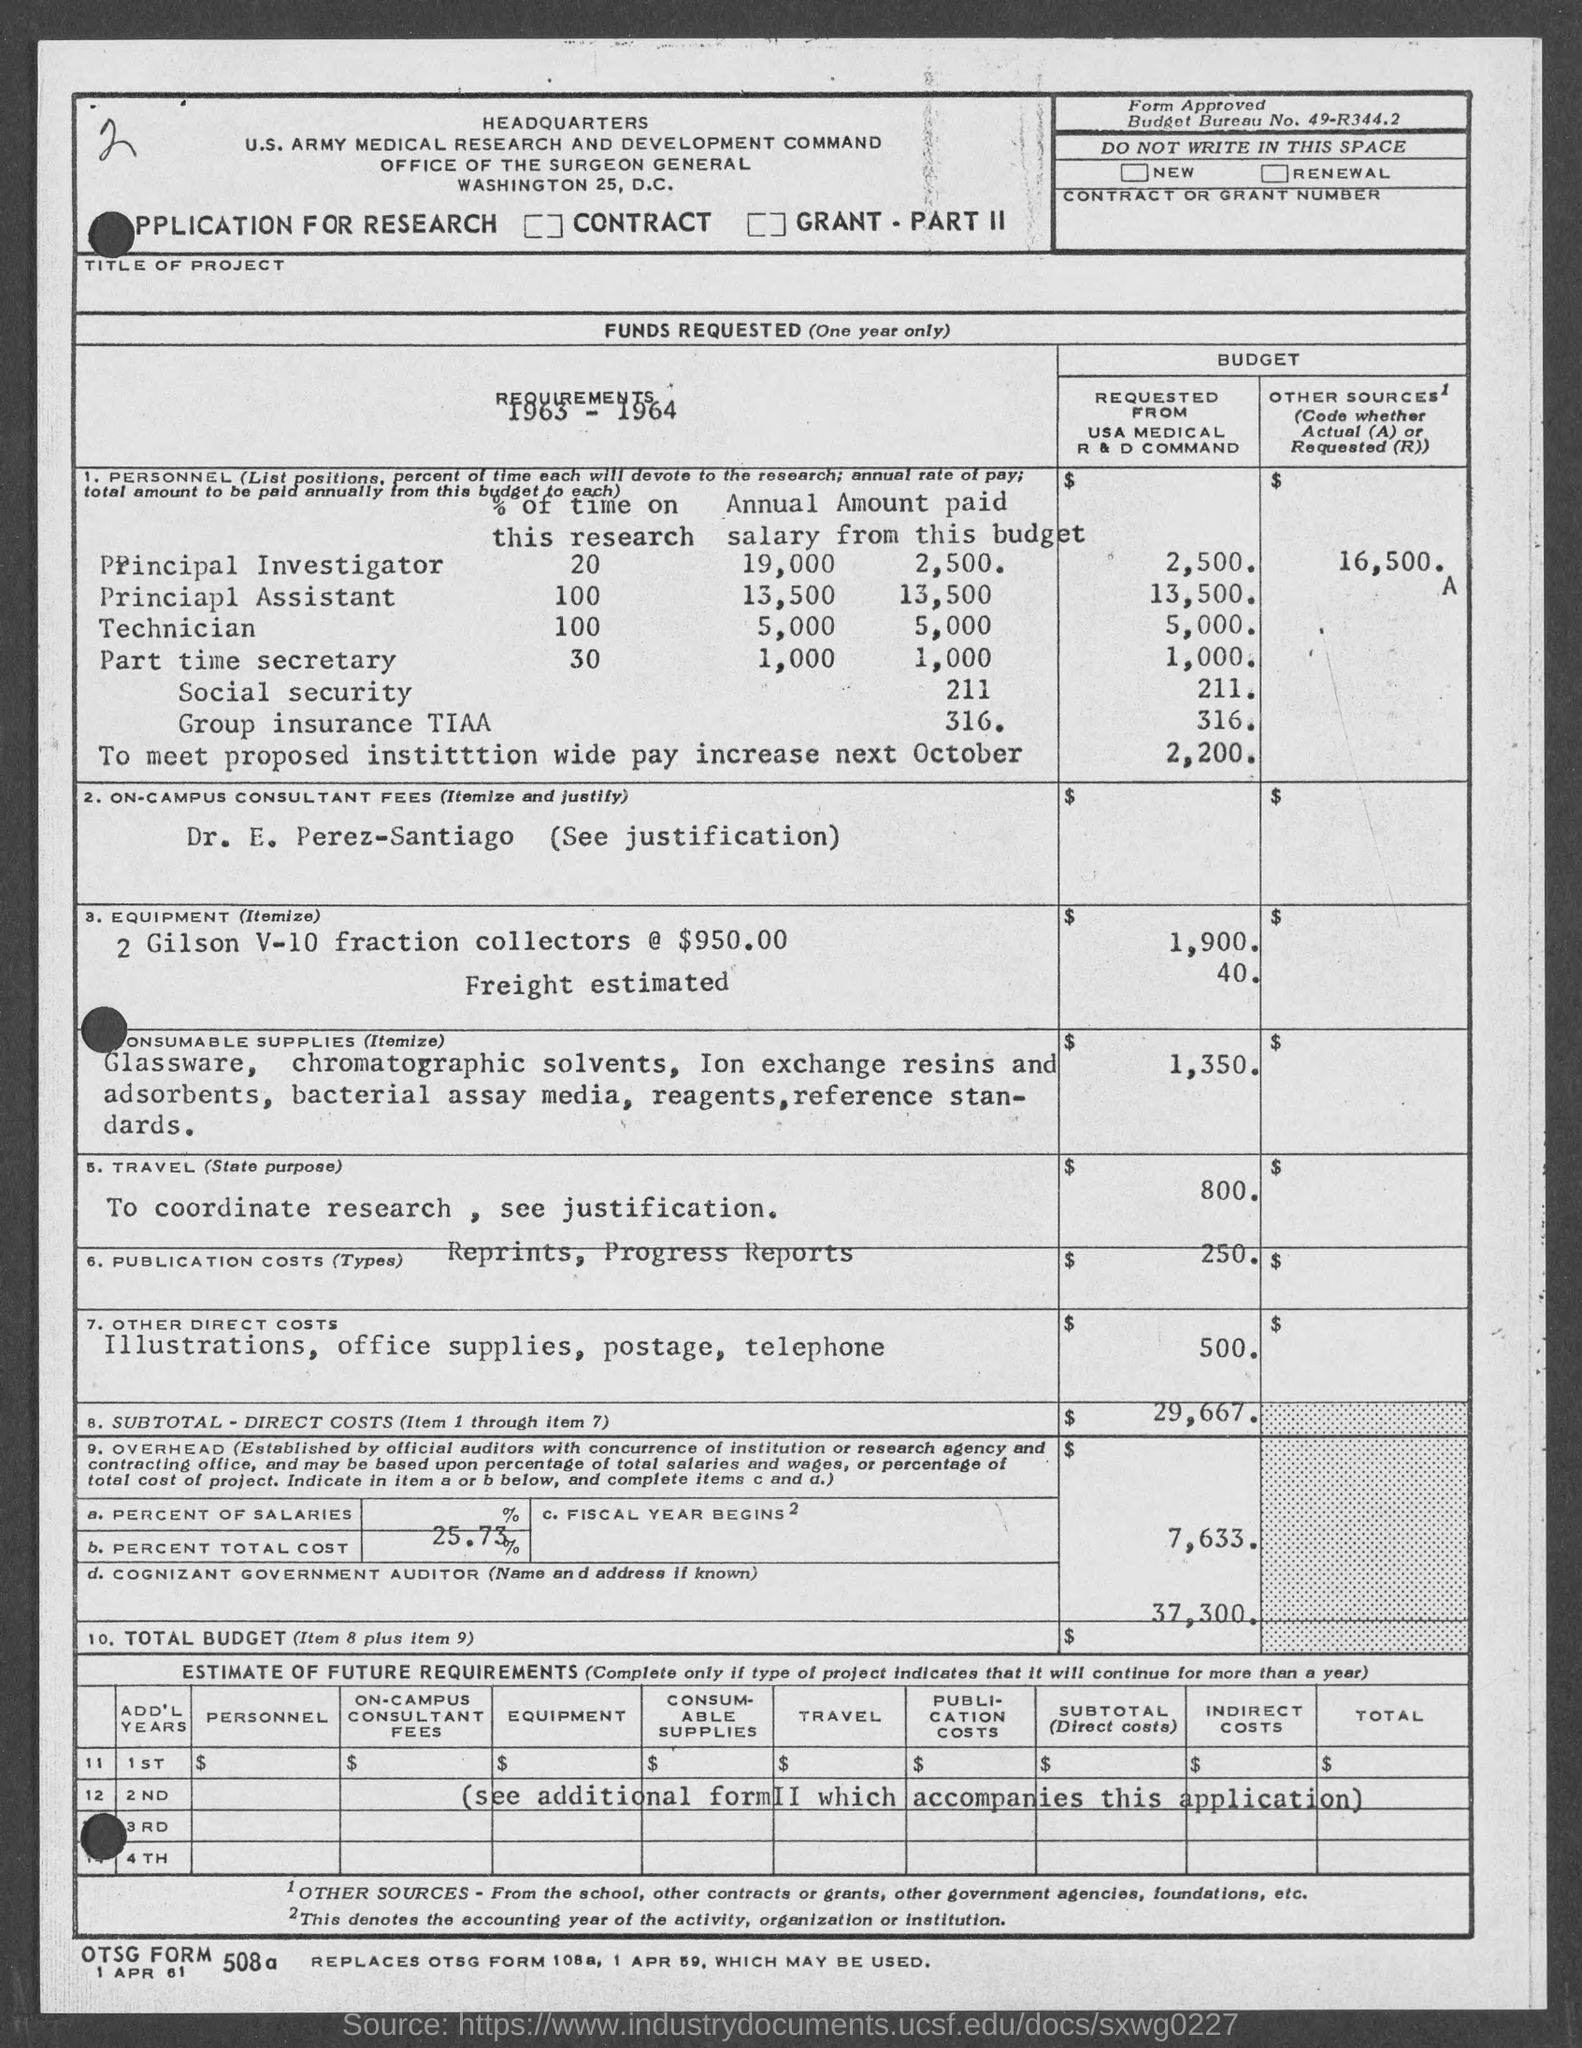Outline some significant characteristics in this image. The principal assistant devoted 100% of their time to research. The annual salary of a Principal assistant is 13,500. The Budget Bureau Number provided in the application is 49-R344.2. The annual payment from this budget to the Principal Assistant is 13,500. The annual salary of a principal investigator is 19,000. 